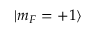Convert formula to latex. <formula><loc_0><loc_0><loc_500><loc_500>| m _ { F } = + 1 \rangle</formula> 